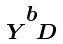<formula> <loc_0><loc_0><loc_500><loc_500>\begin{smallmatrix} b \\ Y \ D \end{smallmatrix}</formula> 